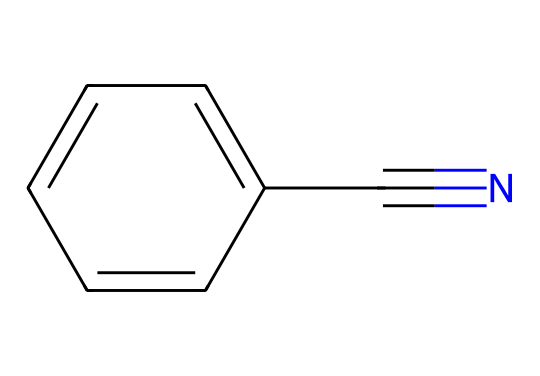What is the molecular formula of benzonitrile? The SMILES representation can be interpreted by breaking it down into its components. The 'c' indicates a carbon atom in an aromatic ring, and 'C#N' represents a cyanide group bonded to the benzene ring, which means there are 7 carbon atoms and 5 hydrogen atoms combined with 1 nitrogen atom. Therefore, the molecular formula is C7H5N.
Answer: C7H5N How many carbon atoms are present in this molecule? By analyzing the structure from the SMILES notation, there are 7 'c' atoms in the aromatic ring and 1 additional 'C' in the cyanide group, making a total of 7 carbon atoms.
Answer: 7 What type of functional group is present in benzonitrile? The SMILES notation shows that the structure contains a cyanide group (C#N), which is a characteristic feature of nitriles. Hence, benzonitrile has a nitrile functional group.
Answer: nitrile What is the total number of hydrogen atoms in benzonitrile? Considering the molecular formula C7H5N from the initial analysis, we can see that it contains 5 hydrogen atoms attached to the benzene ring and the cyanide group does not contribute to hydrogen. Thus, the total number of hydrogen atoms is 5.
Answer: 5 Is benzonitrile a polar or nonpolar molecule? The presence of the polar nitrile group (C#N) contributes to the overall polarity of the molecule, but the benzene ring is largely nonpolar. However, the net effect leads to an overall polar character for benzonitrile.
Answer: polar How many double bonds are present in the molecule? Reviewing the structure, the 'C#N' indicates a triple bond between carbon and nitrogen in the nitrile group, and all rings in the benzene structure contain alternating double bonds, with a total of 3 visible double bonds from a total of 6 carbon atoms. Therefore, there are 3 double bonds in the structure.
Answer: 3 